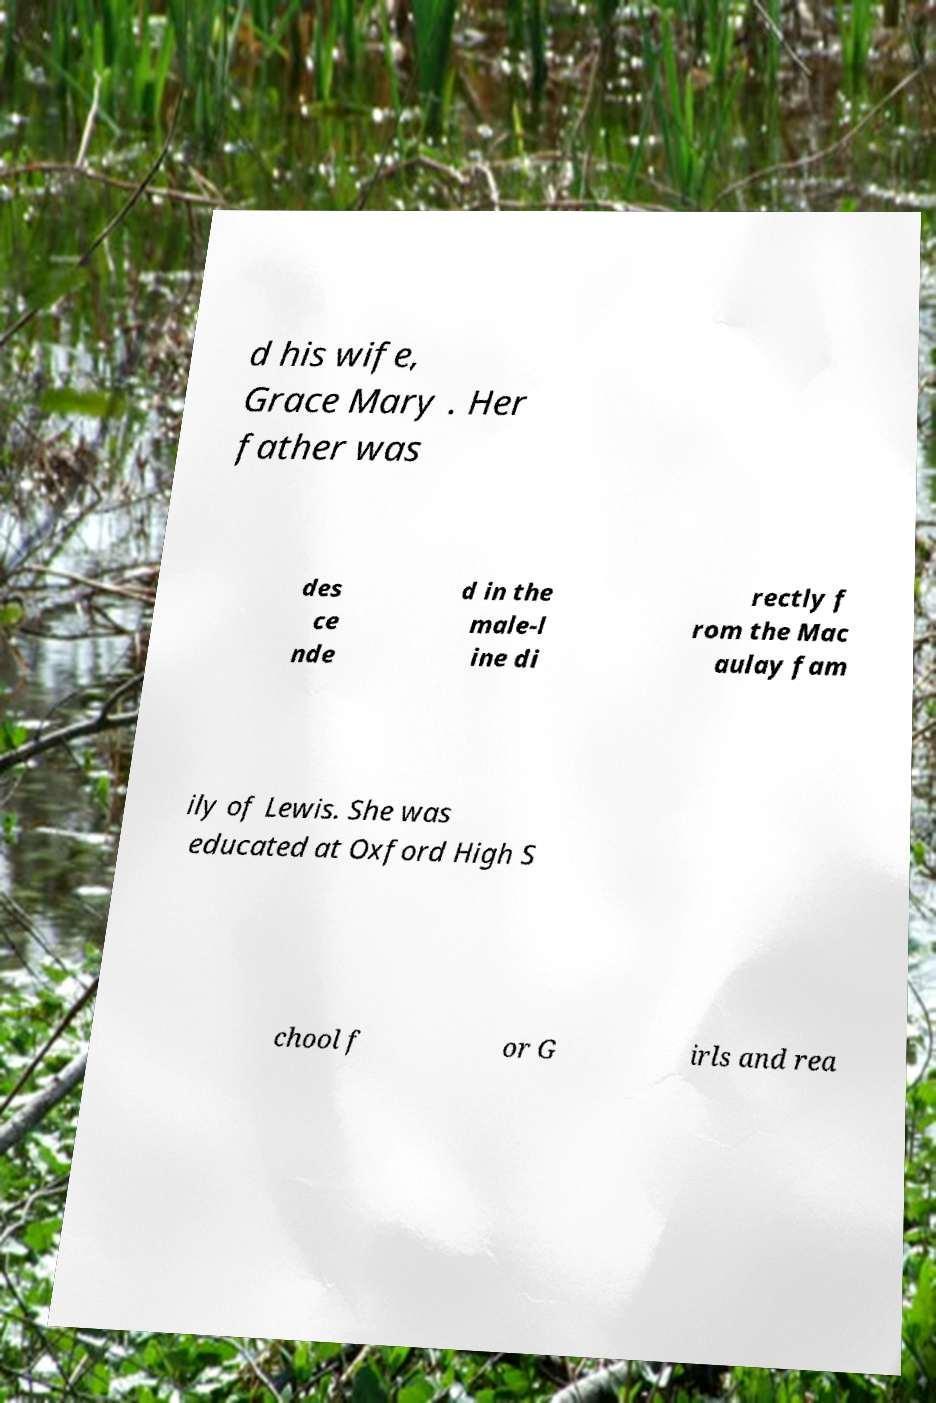Could you extract and type out the text from this image? d his wife, Grace Mary . Her father was des ce nde d in the male-l ine di rectly f rom the Mac aulay fam ily of Lewis. She was educated at Oxford High S chool f or G irls and rea 